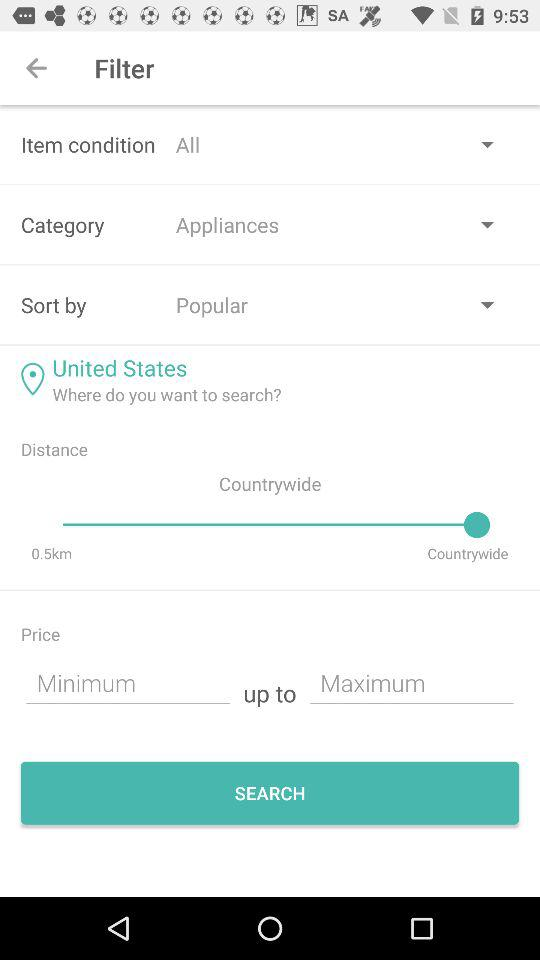What country is shown on the screen? The shown country is the "United States". 